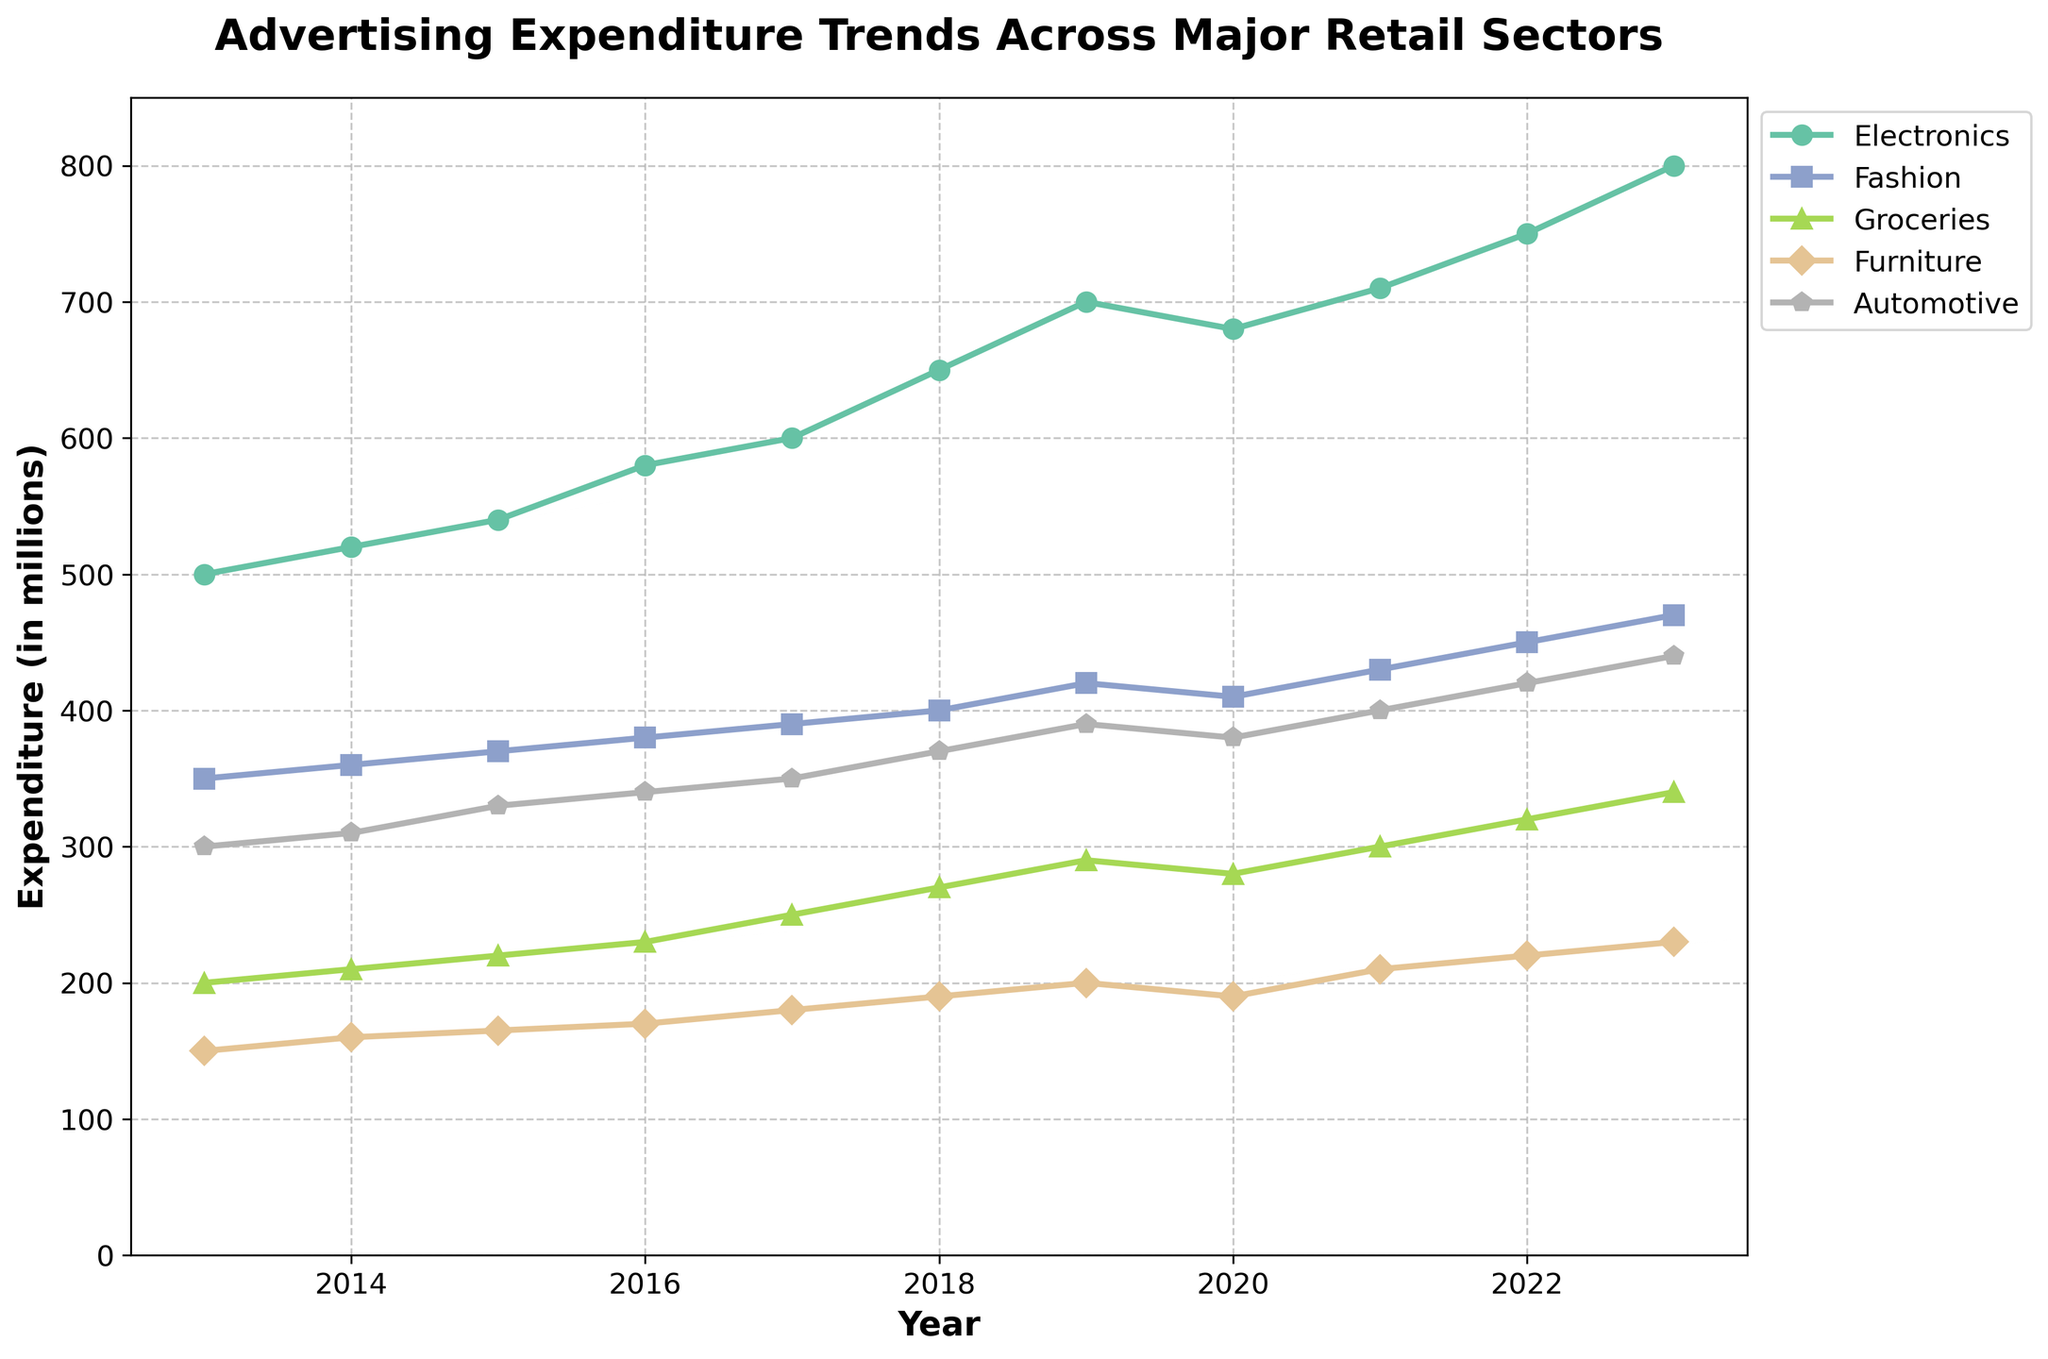What's the title of the figure? The title of the figure is usually placed at the top and describes what the figure represents. Here, the title is "Advertising Expenditure Trends Across Major Retail Sectors", which is right above the plot area.
Answer: Advertising Expenditure Trends Across Major Retail Sectors What is the range of years displayed on the x-axis? The x-axis shows the timeline over which the data is plotted. The range starts from 2013 and ends at 2023, as seen from the x-axis ticks.
Answer: 2013 to 2023 Which sector had the highest advertising expenditure in 2023? By looking at the endpoint of each sector's line on the right side (2023), the Electronics sector reaches the highest point.
Answer: Electronics Which sector had the lowest advertising expenditure in 2016? In 2016, by comparing the points vertically, the Furniture sector is the lowest among all the sectors.
Answer: Furniture How much did the advertising expenditure for Groceries increase from 2013 to 2023? Identify the values for Groceries in 2013 and 2023, then subtract the two values: 340 million (2023) - 200 million (2013) = 140 million.
Answer: 140 million Compare the trends of Electronics and Furniture sectors from 2013 to 2023. Which sector shows a more consistent increase in expenditure? Examine the lines for consistency and slope. Electronics shows a steady increase every year, while Furniture has more variability, especially with a flat trend from 2018 to 2020.
Answer: Electronics Between which consecutive years did Fashion experience the highest increase in advertising expenditure? Calculate the year-on-year increase for Fashion. The largest jump can be seen between 2022 (450 million) and 2023 (470 million), an increase of 20 million.
Answer: 2022 to 2023 What can be inferred about the trend in Automotive expenditure around 2020? Observing the line for Automotive, there is a slight decline in 2020 compared to 2019, followed by a recovery trend. This suggests a temporary dip in advertising expenditure.
Answer: Slight decline followed by recovery What is the total advertising expenditure across all sectors for the year 2020? Sum the expenditures for all sectors in 2020: 680 (Electronics) + 410 (Fashion) + 280 (Groceries) + 190 (Furniture) + 380 (Automotive) = 1940 million.
Answer: 1940 million When did the advertising expenditure for Fashion surpass 400 million? Look at the line for Fashion and find when it crosses the 400 million mark on the y-axis. This occurs in 2018.
Answer: 2018 